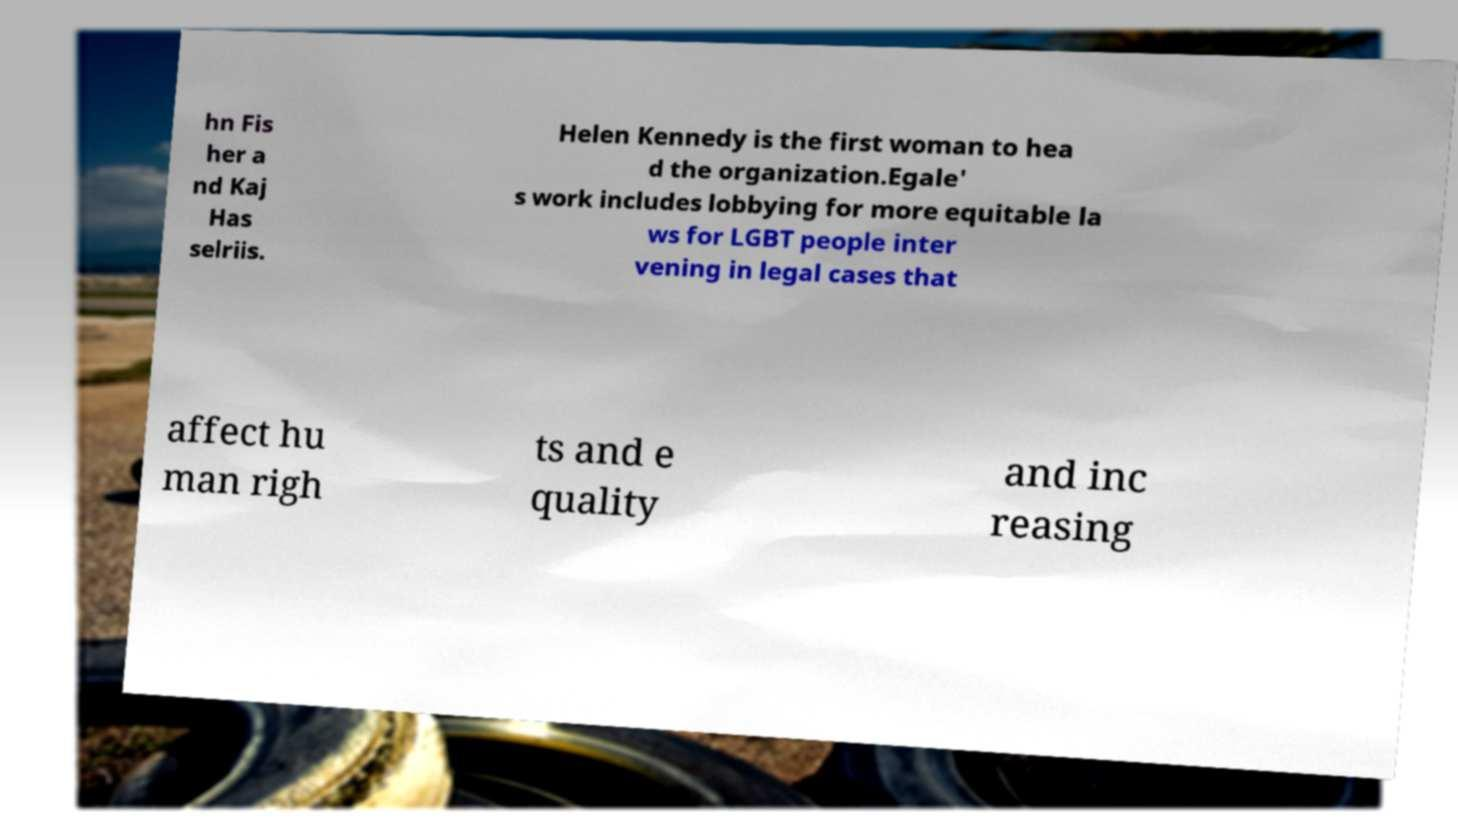Please read and relay the text visible in this image. What does it say? hn Fis her a nd Kaj Has selriis. Helen Kennedy is the first woman to hea d the organization.Egale' s work includes lobbying for more equitable la ws for LGBT people inter vening in legal cases that affect hu man righ ts and e quality and inc reasing 